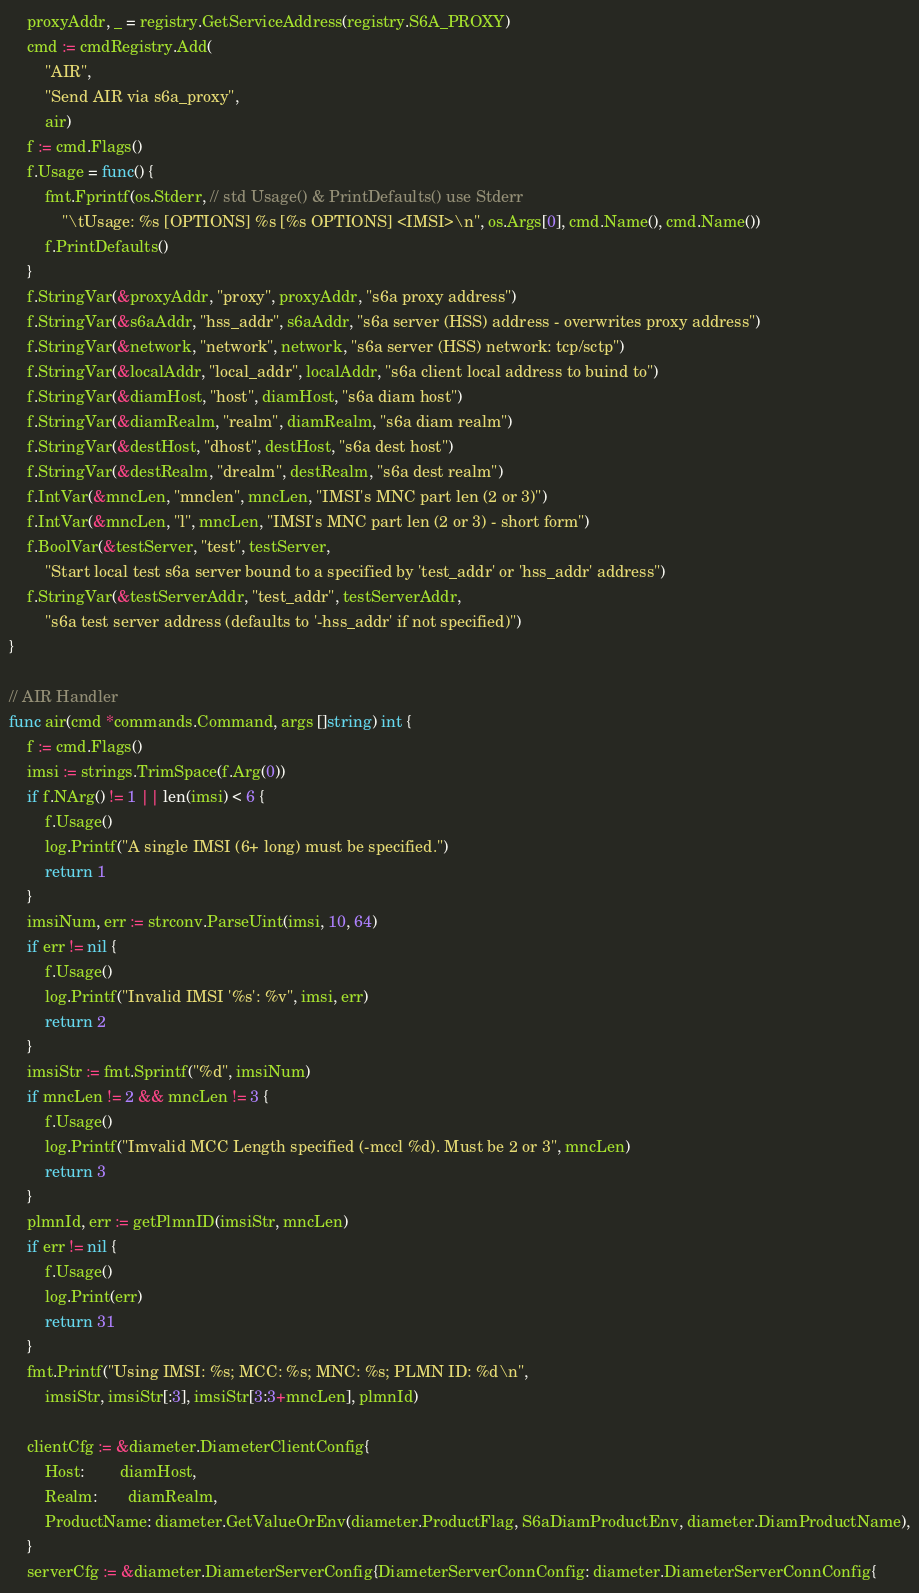Convert code to text. <code><loc_0><loc_0><loc_500><loc_500><_Go_>	proxyAddr, _ = registry.GetServiceAddress(registry.S6A_PROXY)
	cmd := cmdRegistry.Add(
		"AIR",
		"Send AIR via s6a_proxy",
		air)
	f := cmd.Flags()
	f.Usage = func() {
		fmt.Fprintf(os.Stderr, // std Usage() & PrintDefaults() use Stderr
			"\tUsage: %s [OPTIONS] %s [%s OPTIONS] <IMSI>\n", os.Args[0], cmd.Name(), cmd.Name())
		f.PrintDefaults()
	}
	f.StringVar(&proxyAddr, "proxy", proxyAddr, "s6a proxy address")
	f.StringVar(&s6aAddr, "hss_addr", s6aAddr, "s6a server (HSS) address - overwrites proxy address")
	f.StringVar(&network, "network", network, "s6a server (HSS) network: tcp/sctp")
	f.StringVar(&localAddr, "local_addr", localAddr, "s6a client local address to buind to")
	f.StringVar(&diamHost, "host", diamHost, "s6a diam host")
	f.StringVar(&diamRealm, "realm", diamRealm, "s6a diam realm")
	f.StringVar(&destHost, "dhost", destHost, "s6a dest host")
	f.StringVar(&destRealm, "drealm", destRealm, "s6a dest realm")
	f.IntVar(&mncLen, "mnclen", mncLen, "IMSI's MNC part len (2 or 3)")
	f.IntVar(&mncLen, "l", mncLen, "IMSI's MNC part len (2 or 3) - short form")
	f.BoolVar(&testServer, "test", testServer,
		"Start local test s6a server bound to a specified by 'test_addr' or 'hss_addr' address")
	f.StringVar(&testServerAddr, "test_addr", testServerAddr,
		"s6a test server address (defaults to '-hss_addr' if not specified)")
}

// AIR Handler
func air(cmd *commands.Command, args []string) int {
	f := cmd.Flags()
	imsi := strings.TrimSpace(f.Arg(0))
	if f.NArg() != 1 || len(imsi) < 6 {
		f.Usage()
		log.Printf("A single IMSI (6+ long) must be specified.")
		return 1
	}
	imsiNum, err := strconv.ParseUint(imsi, 10, 64)
	if err != nil {
		f.Usage()
		log.Printf("Invalid IMSI '%s': %v", imsi, err)
		return 2
	}
	imsiStr := fmt.Sprintf("%d", imsiNum)
	if mncLen != 2 && mncLen != 3 {
		f.Usage()
		log.Printf("Imvalid MCC Length specified (-mccl %d). Must be 2 or 3", mncLen)
		return 3
	}
	plmnId, err := getPlmnID(imsiStr, mncLen)
	if err != nil {
		f.Usage()
		log.Print(err)
		return 31
	}
	fmt.Printf("Using IMSI: %s; MCC: %s; MNC: %s; PLMN ID: %d\n",
		imsiStr, imsiStr[:3], imsiStr[3:3+mncLen], plmnId)

	clientCfg := &diameter.DiameterClientConfig{
		Host:        diamHost,
		Realm:       diamRealm,
		ProductName: diameter.GetValueOrEnv(diameter.ProductFlag, S6aDiamProductEnv, diameter.DiamProductName),
	}
	serverCfg := &diameter.DiameterServerConfig{DiameterServerConnConfig: diameter.DiameterServerConnConfig{</code> 